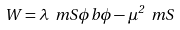<formula> <loc_0><loc_0><loc_500><loc_500>W = \lambda \ m S \phi b \phi - \mu ^ { 2 } \ m S</formula> 